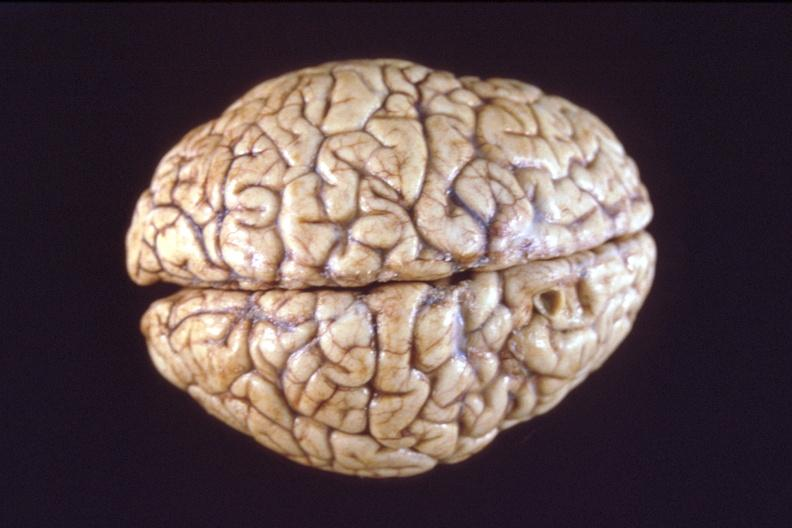does metastatic colon carcinoma show brain, breast cancer metastasis to meninges?
Answer the question using a single word or phrase. No 